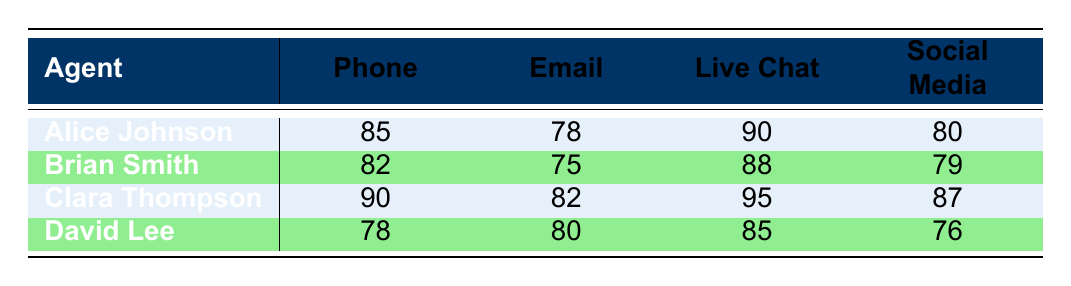What is the customer satisfaction score for Clara Thompson on Live Chat? In the table, I find Clara Thompson's scores under the Live Chat column, which is directly specified. The score is 95.
Answer: 95 Which support agent has the highest score on the Phone channel? By reviewing the Phone scores for all agents—85 for Alice, 82 for Brian, 90 for Clara, and 78 for David—I can see that Clara Thompson has the highest score at 90.
Answer: Clara Thompson What is the average customer satisfaction score for David Lee across all service channels? To calculate David Lee's average, I sum his scores: 78 (Phone) + 80 (Email) + 85 (Live Chat) + 76 (Social Media) = 319. Then, divide by the number of channels (4): 319 / 4 = 79.75.
Answer: 79.75 Is Brian Smith's score on Email higher than that of Alice Johnson? Looking at the Email column, Brian's score is 75 while Alice's score is 78. Since 75 is less than 78, the answer is no.
Answer: No Which support agent has the lowest score on Social Media? Observing the Social Media scores: 80 for Alice, 79 for Brian, 87 for Clara, and 76 for David, David Lee has the lowest score at 76.
Answer: David Lee What is the difference between Clara Thompson's score on Live Chat and David Lee's score on the same channel? Clara's score for Live Chat is 95, and David's score is 85. The difference is calculated as 95 - 85 = 10.
Answer: 10 Does any support agent have the same score on Email? The scores on Email for Alice Johnson and Clara Thompson are 78 and 82 respectively, Brian has 75, and David has 80. Since all scores are unique, the answer is no.
Answer: No What is the total customer satisfaction score for Alice across all channels? To find Alice's total, I add her scores: 85 (Phone) + 78 (Email) + 90 (Live Chat) + 80 (Social Media) = 333.
Answer: 333 Which service channel has the lowest overall score across all agents? I will sum the scores for each service channel: Phone: (85 + 82 + 90 + 78) = 335, Email: (78 + 75 + 82 + 80) = 315, Live Chat: (90 + 88 + 95 + 85) = 358, Social Media: (80 + 79 + 87 + 76) = 322. The lowest total is for Email at 315.
Answer: Email 